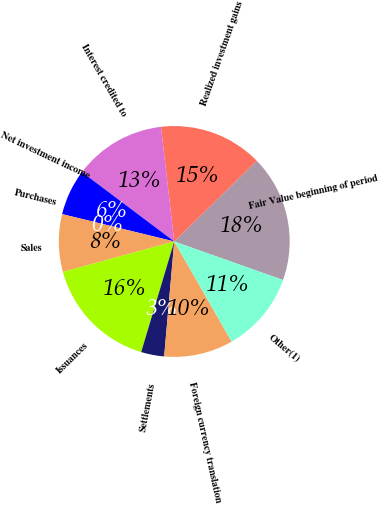<chart> <loc_0><loc_0><loc_500><loc_500><pie_chart><fcel>Fair Value beginning of period<fcel>Realized investment gains<fcel>Interest credited to<fcel>Net investment income<fcel>Purchases<fcel>Sales<fcel>Issuances<fcel>Settlements<fcel>Foreign currency translation<fcel>Other(1)<nl><fcel>17.74%<fcel>14.52%<fcel>12.9%<fcel>6.45%<fcel>0.0%<fcel>8.06%<fcel>16.13%<fcel>3.23%<fcel>9.68%<fcel>11.29%<nl></chart> 